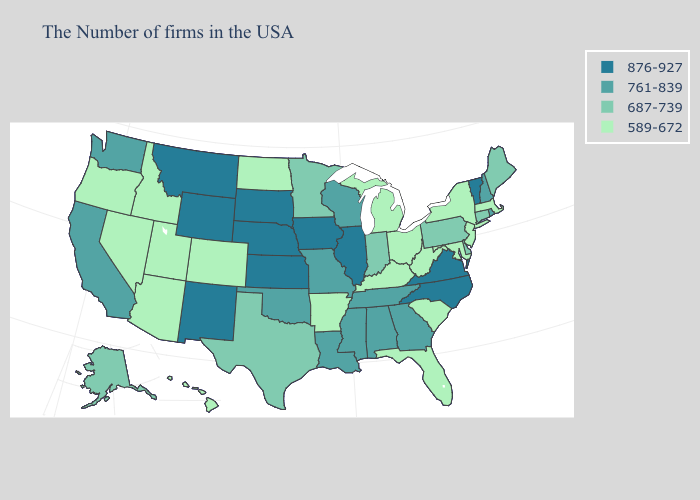What is the value of Ohio?
Answer briefly. 589-672. Name the states that have a value in the range 761-839?
Be succinct. Rhode Island, New Hampshire, Georgia, Alabama, Tennessee, Wisconsin, Mississippi, Louisiana, Missouri, Oklahoma, California, Washington. Does Connecticut have the lowest value in the Northeast?
Write a very short answer. No. What is the value of Minnesota?
Be succinct. 687-739. What is the value of Vermont?
Keep it brief. 876-927. What is the highest value in states that border Oklahoma?
Concise answer only. 876-927. Name the states that have a value in the range 761-839?
Give a very brief answer. Rhode Island, New Hampshire, Georgia, Alabama, Tennessee, Wisconsin, Mississippi, Louisiana, Missouri, Oklahoma, California, Washington. Among the states that border Idaho , which have the highest value?
Keep it brief. Wyoming, Montana. Name the states that have a value in the range 876-927?
Answer briefly. Vermont, Virginia, North Carolina, Illinois, Iowa, Kansas, Nebraska, South Dakota, Wyoming, New Mexico, Montana. Does the map have missing data?
Short answer required. No. Among the states that border Rhode Island , which have the lowest value?
Answer briefly. Massachusetts. What is the highest value in the USA?
Write a very short answer. 876-927. Which states have the lowest value in the USA?
Short answer required. Massachusetts, New York, New Jersey, Maryland, South Carolina, West Virginia, Ohio, Florida, Michigan, Kentucky, Arkansas, North Dakota, Colorado, Utah, Arizona, Idaho, Nevada, Oregon, Hawaii. Name the states that have a value in the range 876-927?
Quick response, please. Vermont, Virginia, North Carolina, Illinois, Iowa, Kansas, Nebraska, South Dakota, Wyoming, New Mexico, Montana. Does Oklahoma have the highest value in the USA?
Answer briefly. No. 